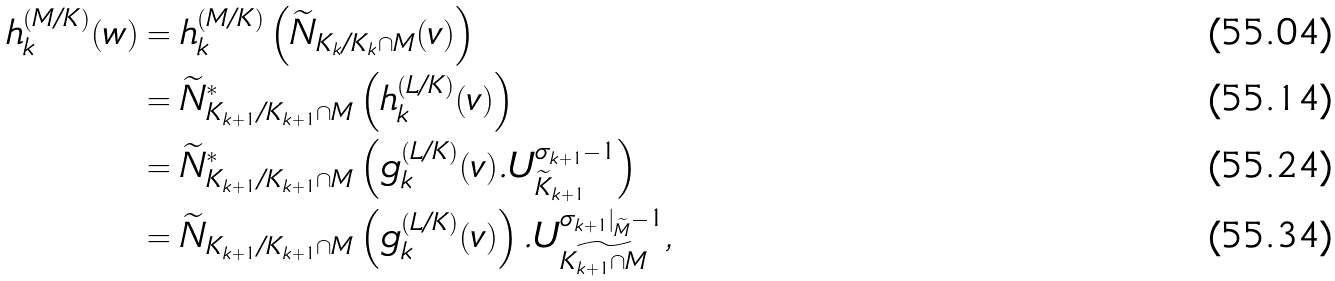<formula> <loc_0><loc_0><loc_500><loc_500>h _ { k } ^ { ( M / K ) } ( w ) & = h _ { k } ^ { ( M / K ) } \left ( \widetilde { N } _ { K _ { k } / K _ { k } \cap M } ( v ) \right ) \\ & = \widetilde { N } ^ { * } _ { K _ { k + 1 } / K _ { k + 1 } \cap M } \left ( h _ { k } ^ { ( L / K ) } ( v ) \right ) \\ & = \widetilde { N } ^ { * } _ { K _ { k + 1 } / K _ { k + 1 } \cap M } \left ( g _ { k } ^ { ( L / K ) } ( v ) . U _ { \widetilde { K } _ { k + 1 } } ^ { \sigma _ { k + 1 } - 1 } \right ) \\ & = \widetilde { N } _ { K _ { k + 1 } / K _ { k + 1 } \cap M } \left ( g _ { k } ^ { ( L / K ) } ( v ) \right ) . U _ { \widetilde { K _ { k + 1 } \cap M } } ^ { \sigma _ { k + 1 } | _ { \widetilde { M } } - 1 } ,</formula> 